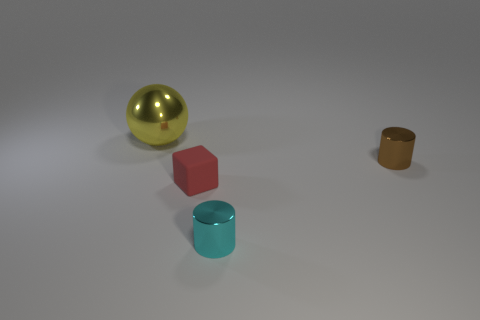Add 3 matte spheres. How many objects exist? 7 Subtract all cubes. How many objects are left? 3 Add 2 rubber things. How many rubber things exist? 3 Subtract 0 yellow cylinders. How many objects are left? 4 Subtract all tiny red matte objects. Subtract all big brown rubber cylinders. How many objects are left? 3 Add 4 small cubes. How many small cubes are left? 5 